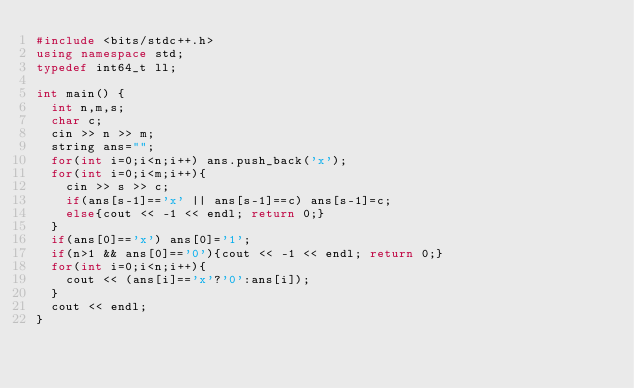<code> <loc_0><loc_0><loc_500><loc_500><_C++_>#include <bits/stdc++.h>
using namespace std;
typedef int64_t ll;

int main() {
  int n,m,s;
  char c;
  cin >> n >> m;
  string ans="";
  for(int i=0;i<n;i++) ans.push_back('x');
  for(int i=0;i<m;i++){
    cin >> s >> c;
    if(ans[s-1]=='x' || ans[s-1]==c) ans[s-1]=c;
    else{cout << -1 << endl; return 0;}
  }
  if(ans[0]=='x') ans[0]='1';
  if(n>1 && ans[0]=='0'){cout << -1 << endl; return 0;}
  for(int i=0;i<n;i++){
    cout << (ans[i]=='x'?'0':ans[i]);
  }
  cout << endl;
}
</code> 